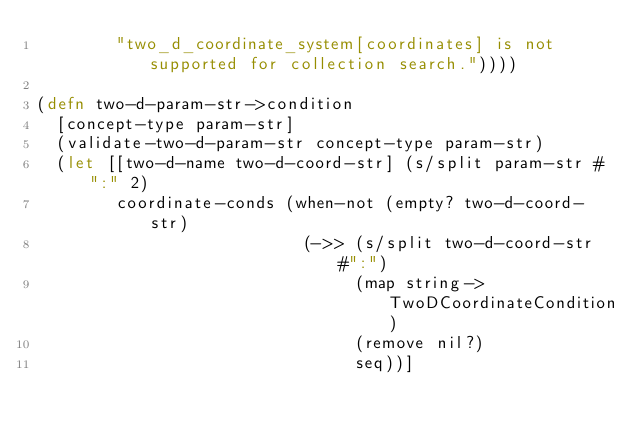<code> <loc_0><loc_0><loc_500><loc_500><_Clojure_>        "two_d_coordinate_system[coordinates] is not supported for collection search."))))

(defn two-d-param-str->condition
  [concept-type param-str]
  (validate-two-d-param-str concept-type param-str)
  (let [[two-d-name two-d-coord-str] (s/split param-str #":" 2)
        coordinate-conds (when-not (empty? two-d-coord-str)
                           (->> (s/split two-d-coord-str #":")
                                (map string->TwoDCoordinateCondition)
                                (remove nil?)
                                seq))]</code> 